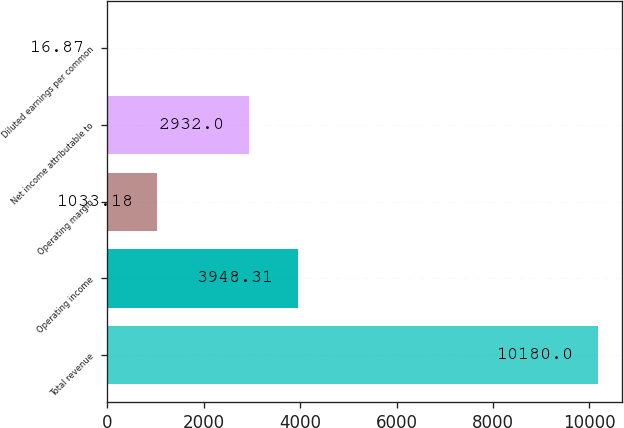Convert chart. <chart><loc_0><loc_0><loc_500><loc_500><bar_chart><fcel>Total revenue<fcel>Operating income<fcel>Operating margin<fcel>Net income attributable to<fcel>Diluted earnings per common<nl><fcel>10180<fcel>3948.31<fcel>1033.18<fcel>2932<fcel>16.87<nl></chart> 